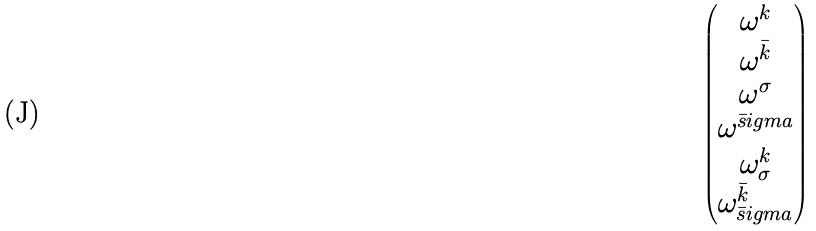Convert formula to latex. <formula><loc_0><loc_0><loc_500><loc_500>\begin{pmatrix} \omega ^ { k } \\ \omega ^ { \bar { k } } \\ \omega ^ { \sigma } \\ \omega ^ { \bar { s } i g m a } \\ \omega ^ { k } _ { \sigma } \\ \omega ^ { \bar { k } } _ { \bar { s } i g m a } \end{pmatrix}</formula> 